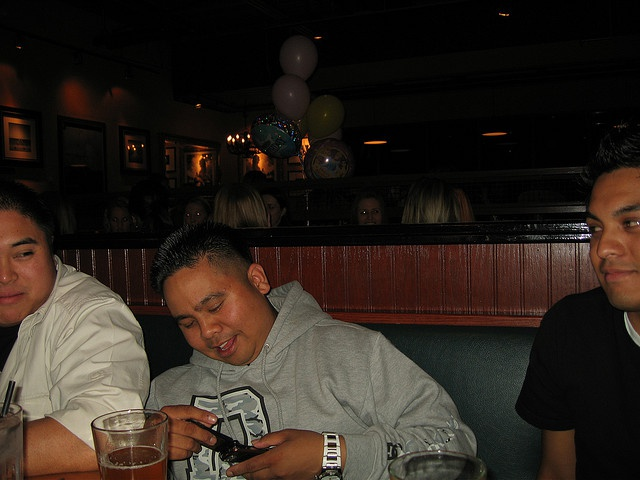Describe the objects in this image and their specific colors. I can see people in black, gray, maroon, and brown tones, people in black, darkgray, gray, and brown tones, people in black, maroon, and brown tones, couch in black, maroon, and gray tones, and cup in black, maroon, and gray tones in this image. 